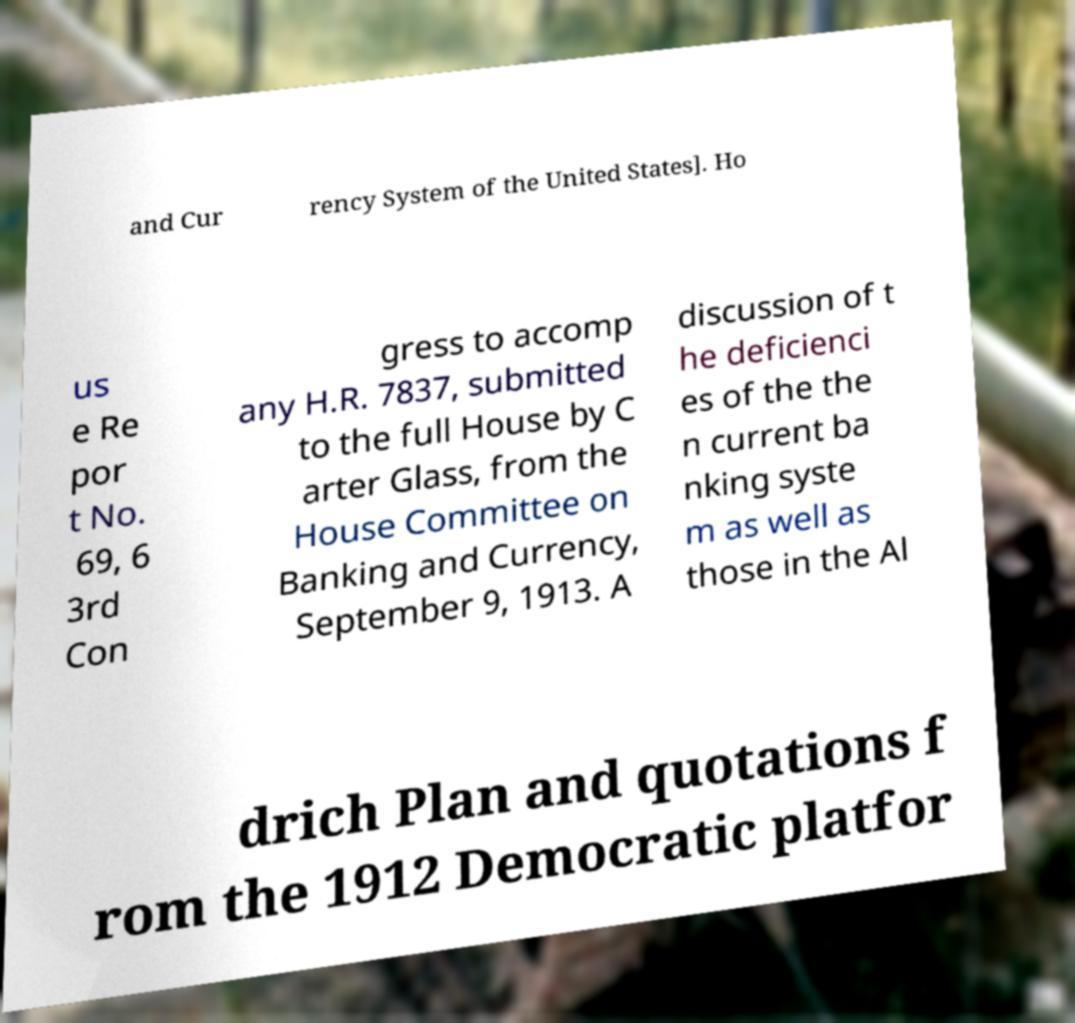Could you extract and type out the text from this image? and Cur rency System of the United States]. Ho us e Re por t No. 69, 6 3rd Con gress to accomp any H.R. 7837, submitted to the full House by C arter Glass, from the House Committee on Banking and Currency, September 9, 1913. A discussion of t he deficienci es of the the n current ba nking syste m as well as those in the Al drich Plan and quotations f rom the 1912 Democratic platfor 